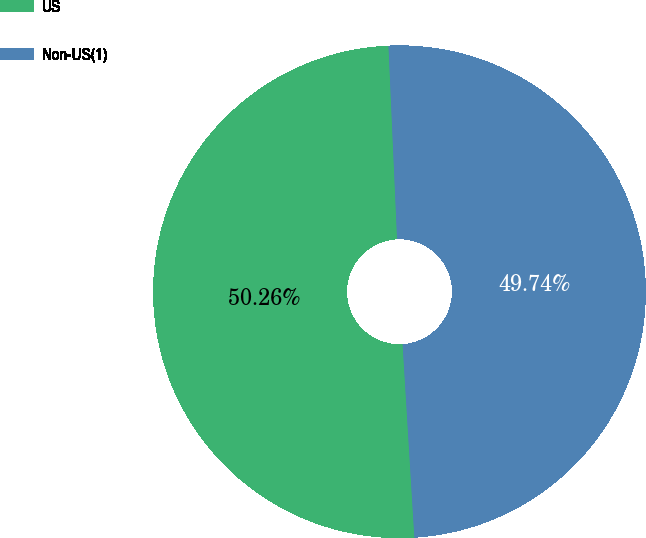Convert chart to OTSL. <chart><loc_0><loc_0><loc_500><loc_500><pie_chart><fcel>US<fcel>Non-US(1)<nl><fcel>50.26%<fcel>49.74%<nl></chart> 